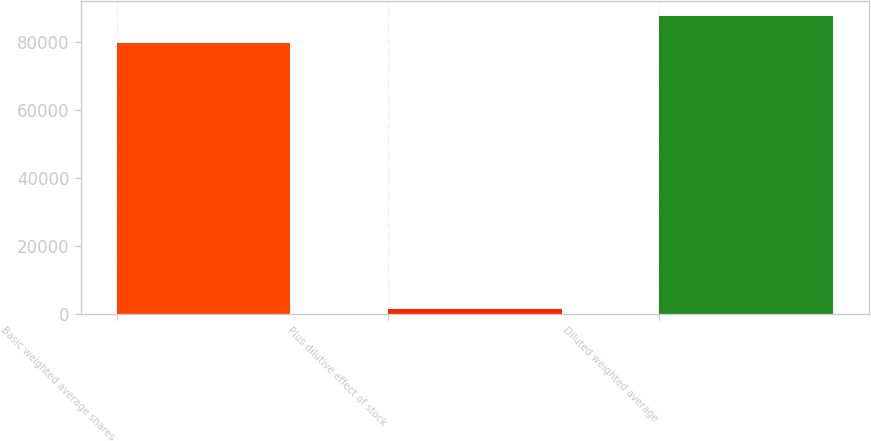Convert chart to OTSL. <chart><loc_0><loc_0><loc_500><loc_500><bar_chart><fcel>Basic weighted average shares<fcel>Plus dilutive effect of stock<fcel>Diluted weighted average<nl><fcel>79765<fcel>1371<fcel>87741.5<nl></chart> 